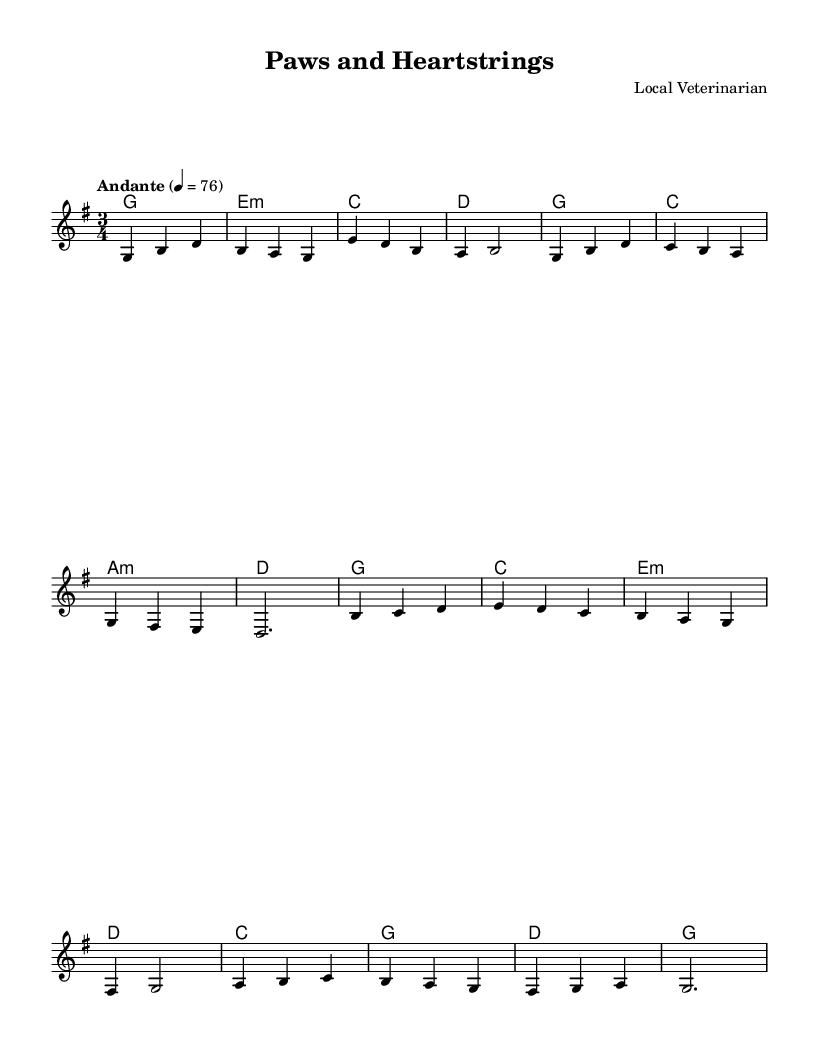What is the key signature of this music? The key signature is G major, which has one sharp (F#). This can be determined by looking at the key signature indicated at the beginning of the sheet music.
Answer: G major What is the time signature of this music? The time signature is 3/4, which means there are three beats in each measure and the quarter note gets one beat. This is located at the beginning of the sheet music.
Answer: 3/4 What is the tempo marking for this piece? The tempo marking is "Andante," indicating a moderate pace. This is typically placed at the beginning of the score.
Answer: Andante How many measures are in the composition? There are 12 measures in total. To find this, count each set of vertical bar lines that denote the end of each measure throughout the piece.
Answer: 12 What type of chords are predominantly used in this piece? The piece predominantly uses major and minor chords, as indicated by the chord symbols above the staff. The sequence of chords includes G, E minor, C, and D.
Answer: Major and minor How does the melody reflect the Romantic style? The melody features lyrical phrases, expressive dynamics, and a focus on emotion, characteristic of the Romantic style. The use of gentle flows and rises in pitch enhances this feeling.
Answer: Lyrical and expressive What is the highest note in the melody? The highest note in the melody is D. This can be identified by examining the notes written in the melody line, specifically looking for the note that appears the furthest above the others.
Answer: D 